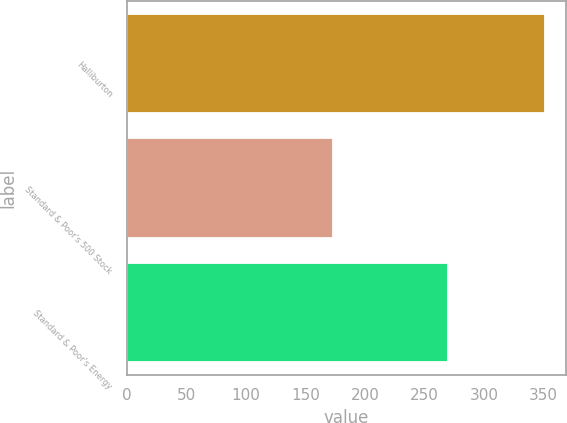Convert chart to OTSL. <chart><loc_0><loc_0><loc_500><loc_500><bar_chart><fcel>Halliburton<fcel>Standard & Poor's 500 Stock<fcel>Standard & Poor's Energy<nl><fcel>351.09<fcel>173.34<fcel>269.64<nl></chart> 